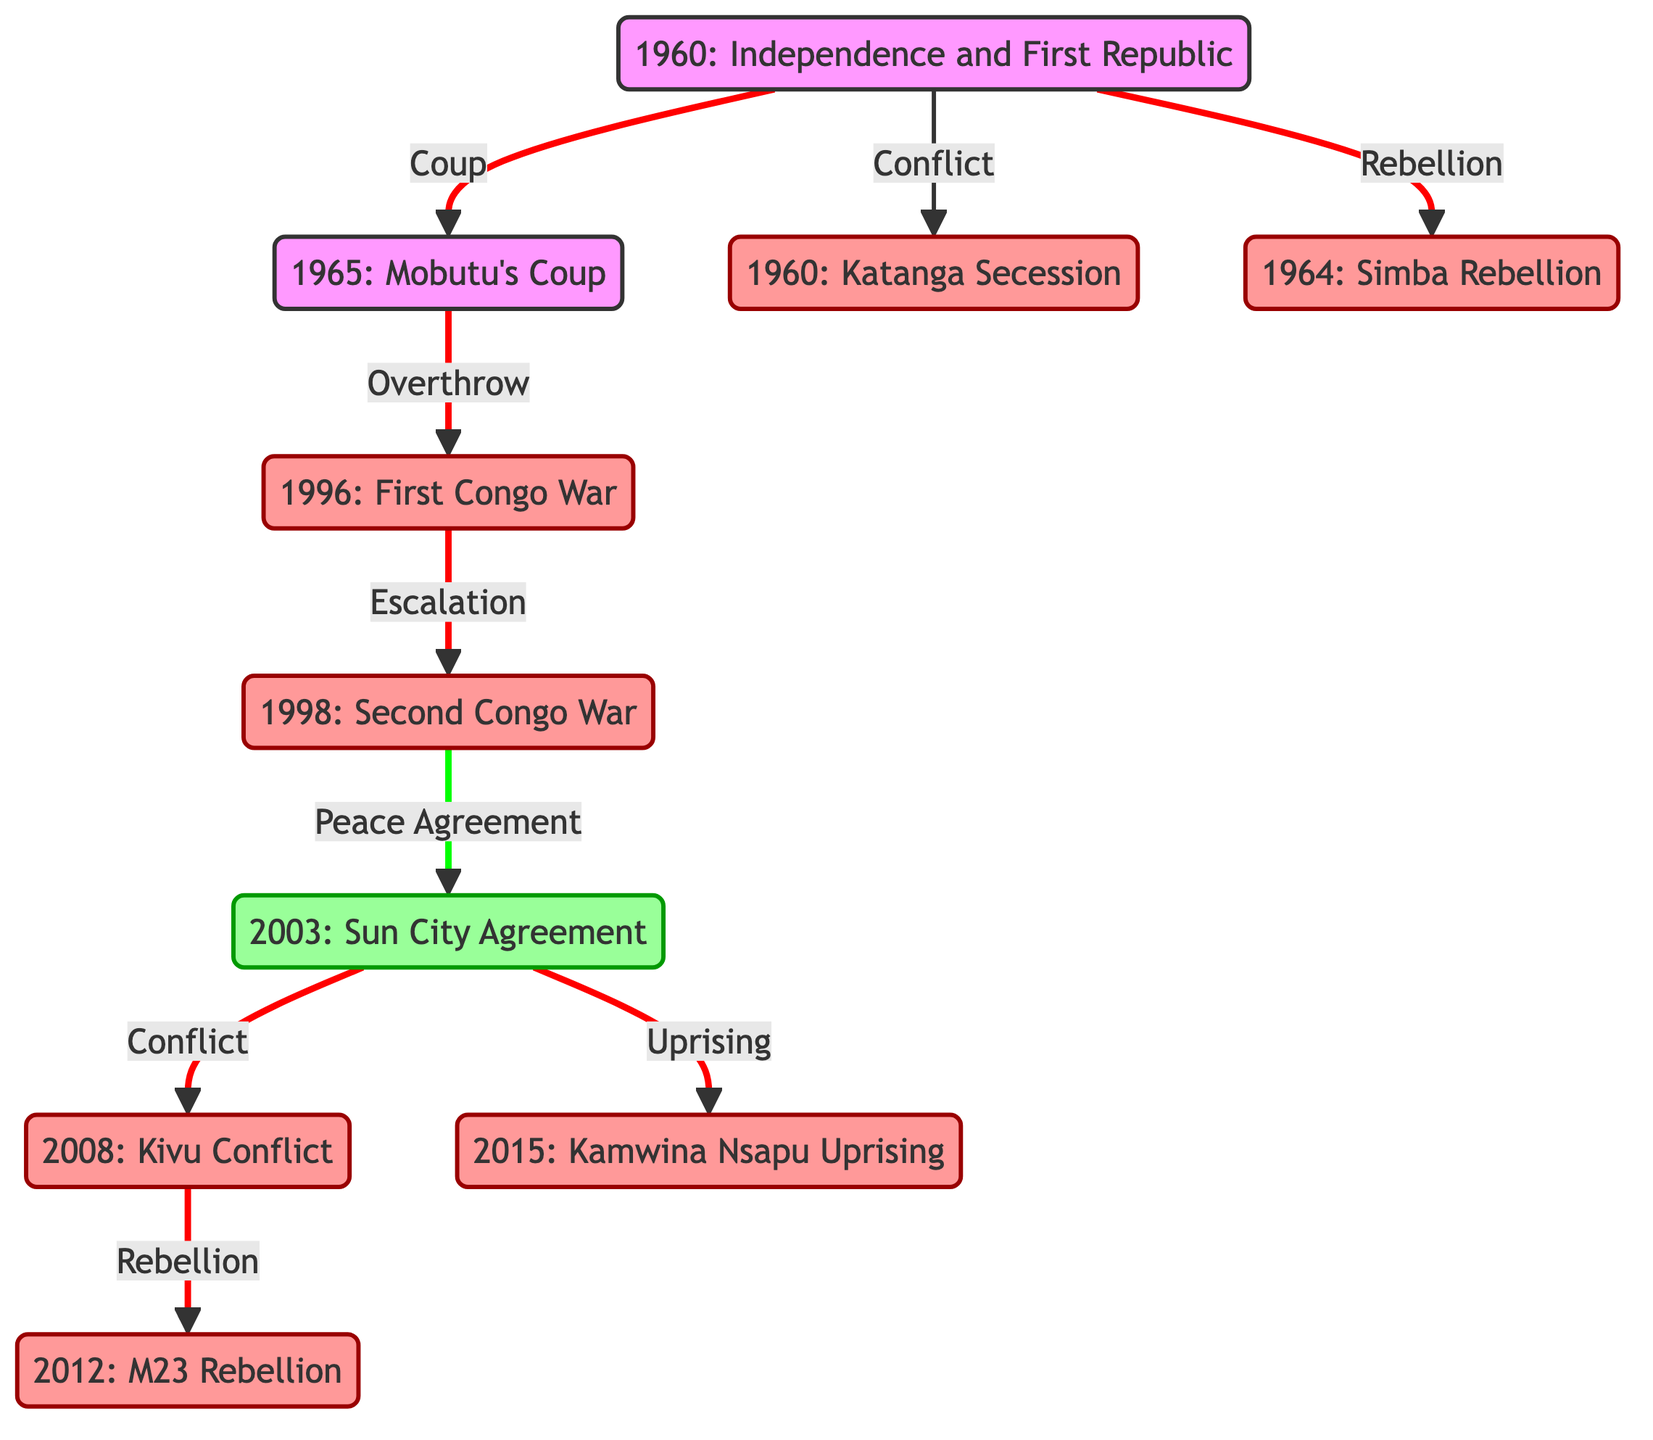What year did Congo gain independence from Belgium? The diagram indicates that Congo gained independence in 1960, as this event is marked as the first node in the graph.
Answer: 1960 How many major rebellions are depicted in this graph? By counting the nodes labeled as rebellions, we identify the following: 1960 Katanga Secession, 1964 Simba Rebellion, 1996 First Congo War, 1998 Second Congo War, 2008 Kivu Conflict, 2012 M23 Rebellion, and 2015 Kamwina Nsapu Uprising. This totals to seven rebellions.
Answer: 7 What event led directly to the Mobutu's coup in 1965? The Mobutu's coup in 1965 is directly linked from the 1960 independence through the label of "Coup," indicating it was a reaction to the instability following independence.
Answer: Coup What is the relationship between the 2003 Sun City Agreement and the 1998 Second Congo War? The diagram shows that the 1998 Second Congo War leads to the 2003 Sun City Agreement through the label "Peace Agreement," indicating that the war's escalation resulted in this peace process.
Answer: Peace Agreement Which rebellion followed the 2008 Kivu Conflict? According to the diagram, the rebellion that follows the 2008 Kivu Conflict is the 2012 M23 Rebellion, which is connected through the "Rebellion" label.
Answer: 2012 M23 Rebellion What percentage of the edges in the diagram are related to rebellion? The diagram shows a total of nine edges and six of them are labeled as rebellions (edges leading to the six rebellion nodes). To find the percentage, divide the number of rebellion edges (6) by the total number of edges (9) and then multiply by 100, resulting in approximately 66.67%.
Answer: 66.67% Which event is indicated as an escalation in severity after the 1996 First Congo War? The diagram directly connects the 1996 First Congo War to the 1998 Second Congo War with the label "Escalation," indicating that this second war was a continuation of prior conflict.
Answer: Second Congo War What is the earliest event shown in the diagram? The diagram starts with the 1960 event labeled "Independence and First Republic," making it the earliest event depicted.
Answer: Independence and First Republic 